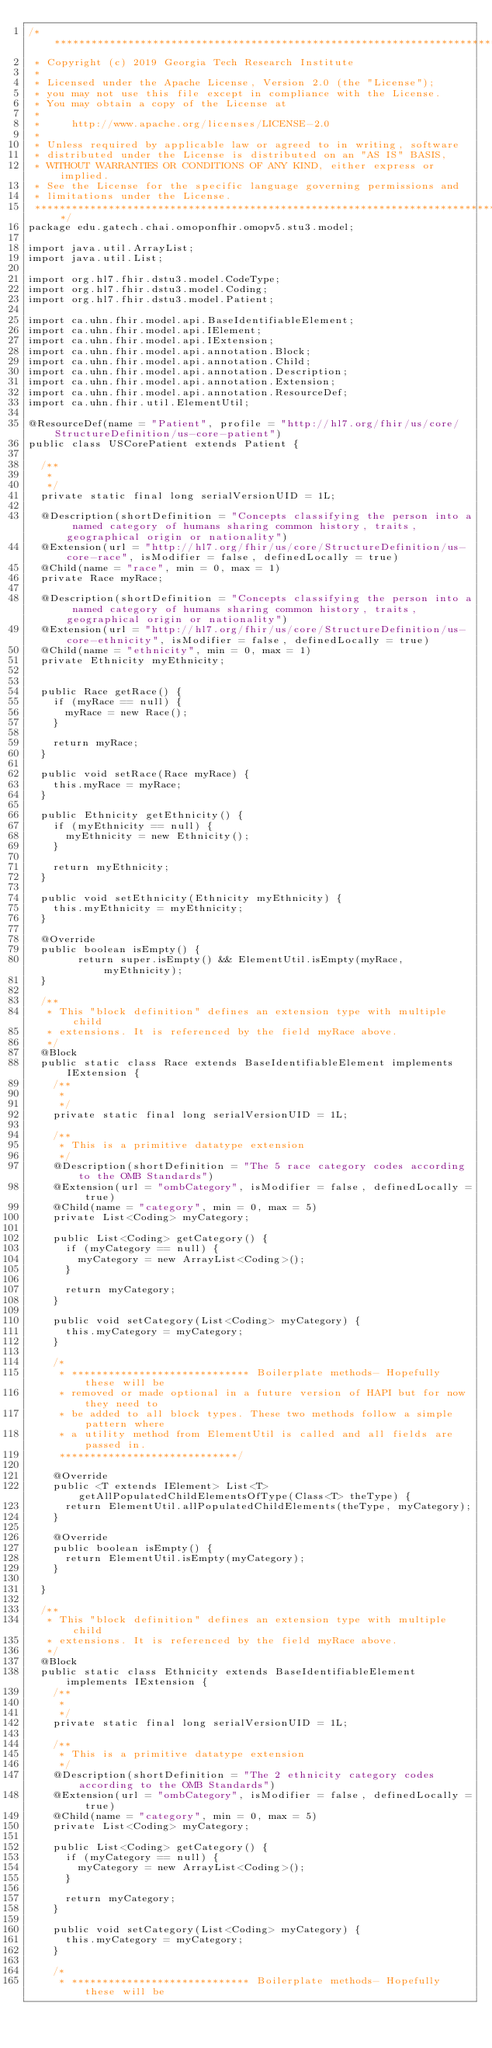Convert code to text. <code><loc_0><loc_0><loc_500><loc_500><_Java_>/*******************************************************************************
 * Copyright (c) 2019 Georgia Tech Research Institute
 *
 * Licensed under the Apache License, Version 2.0 (the "License");
 * you may not use this file except in compliance with the License.
 * You may obtain a copy of the License at
 *
 *     http://www.apache.org/licenses/LICENSE-2.0
 *
 * Unless required by applicable law or agreed to in writing, software
 * distributed under the License is distributed on an "AS IS" BASIS,
 * WITHOUT WARRANTIES OR CONDITIONS OF ANY KIND, either express or implied.
 * See the License for the specific language governing permissions and
 * limitations under the License.
 *******************************************************************************/
package edu.gatech.chai.omoponfhir.omopv5.stu3.model;

import java.util.ArrayList;
import java.util.List;

import org.hl7.fhir.dstu3.model.CodeType;
import org.hl7.fhir.dstu3.model.Coding;
import org.hl7.fhir.dstu3.model.Patient;

import ca.uhn.fhir.model.api.BaseIdentifiableElement;
import ca.uhn.fhir.model.api.IElement;
import ca.uhn.fhir.model.api.IExtension;
import ca.uhn.fhir.model.api.annotation.Block;
import ca.uhn.fhir.model.api.annotation.Child;
import ca.uhn.fhir.model.api.annotation.Description;
import ca.uhn.fhir.model.api.annotation.Extension;
import ca.uhn.fhir.model.api.annotation.ResourceDef;
import ca.uhn.fhir.util.ElementUtil;

@ResourceDef(name = "Patient", profile = "http://hl7.org/fhir/us/core/StructureDefinition/us-core-patient")
public class USCorePatient extends Patient {

	/**
	 * 
	 */
	private static final long serialVersionUID = 1L;

	@Description(shortDefinition = "Concepts classifying the person into a named category of humans sharing common history, traits, geographical origin or nationality")
	@Extension(url = "http://hl7.org/fhir/us/core/StructureDefinition/us-core-race", isModifier = false, definedLocally = true)
	@Child(name = "race", min = 0, max = 1)
	private Race myRace;

	@Description(shortDefinition = "Concepts classifying the person into a named category of humans sharing common history, traits, geographical origin or nationality")
	@Extension(url = "http://hl7.org/fhir/us/core/StructureDefinition/us-core-ethnicity", isModifier = false, definedLocally = true)
	@Child(name = "ethnicity", min = 0, max = 1)
	private Ethnicity myEthnicity;

	
	public Race getRace() {
		if (myRace == null) {
			myRace = new Race();
		} 
		
		return myRace;
	}
	
	public void setRace(Race myRace) {
		this.myRace = myRace;
	}
	
	public Ethnicity getEthnicity() {
		if (myEthnicity == null) {
			myEthnicity = new Ethnicity();
		}
		
		return myEthnicity;
	}
	
	public void setEthnicity(Ethnicity myEthnicity) {
		this.myEthnicity = myEthnicity;
	}
	
	@Override
	public boolean isEmpty() {
        return super.isEmpty() && ElementUtil.isEmpty(myRace, myEthnicity);
	}

	/**
	 * This "block definition" defines an extension type with multiple child
	 * extensions. It is referenced by the field myRace above.
	 */
	@Block
	public static class Race extends BaseIdentifiableElement implements IExtension {
		/**
		 * 
		 */
		private static final long serialVersionUID = 1L;

		/**
		 * This is a primitive datatype extension
		 */
		@Description(shortDefinition = "The 5 race category codes according to the OMB Standards")
		@Extension(url = "ombCategory", isModifier = false, definedLocally = true)
		@Child(name = "category", min = 0, max = 5)
		private List<Coding> myCategory;

		public List<Coding> getCategory() {
			if (myCategory == null) {
				myCategory = new ArrayList<Coding>();
			}
			
			return myCategory;
		}

		public void setCategory(List<Coding> myCategory) {
			this.myCategory = myCategory;
		}

		/*
		 * ***************************** Boilerplate methods- Hopefully these will be
		 * removed or made optional in a future version of HAPI but for now they need to
		 * be added to all block types. These two methods follow a simple pattern where
		 * a utility method from ElementUtil is called and all fields are passed in.
		 *****************************/

		@Override
		public <T extends IElement> List<T> getAllPopulatedChildElementsOfType(Class<T> theType) {
			return ElementUtil.allPopulatedChildElements(theType, myCategory);
		}

		@Override
		public boolean isEmpty() {
			return ElementUtil.isEmpty(myCategory);
		}

	}
	
	/**
	 * This "block definition" defines an extension type with multiple child
	 * extensions. It is referenced by the field myRace above.
	 */
	@Block
	public static class Ethnicity extends BaseIdentifiableElement implements IExtension {
		/**
		 * 
		 */
		private static final long serialVersionUID = 1L;

		/**
		 * This is a primitive datatype extension
		 */
		@Description(shortDefinition = "The 2 ethnicity category codes according to the OMB Standards")
		@Extension(url = "ombCategory", isModifier = false, definedLocally = true)
		@Child(name = "category", min = 0, max = 5)
		private List<Coding> myCategory;

		public List<Coding> getCategory() {
			if (myCategory == null) {
				myCategory = new ArrayList<Coding>();
			}
			
			return myCategory;
		}

		public void setCategory(List<Coding> myCategory) {
			this.myCategory = myCategory;
		}

		/*
		 * ***************************** Boilerplate methods- Hopefully these will be</code> 